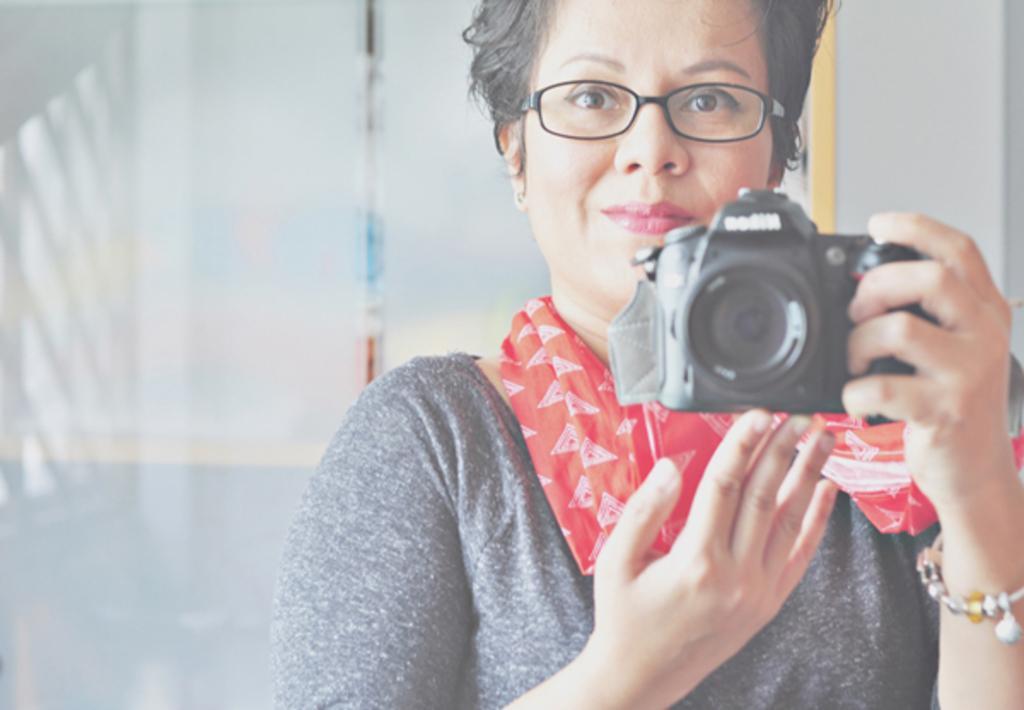Please provide a concise description of this image. In the image we can see there is a woman who is carrying camera in her hand. 